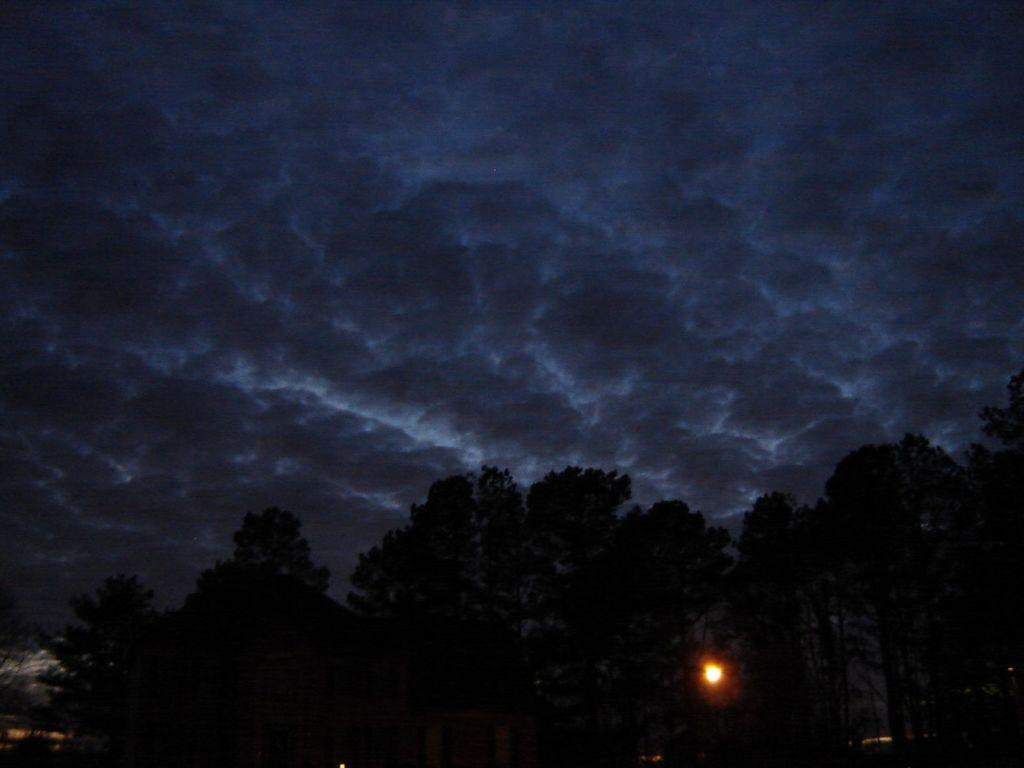What type of vegetation is present in the image? There are many trees in the image. What can be seen in the sky in the image? There are clouds in the sky in the image. Can you describe the light visible between the trees? Yes, there is a light visible between the trees. How many clovers can be seen growing among the trees in the image? There are no clovers visible in the image; it only features trees and a light. Is there an arch visible in the image? There is no arch present in the image. 